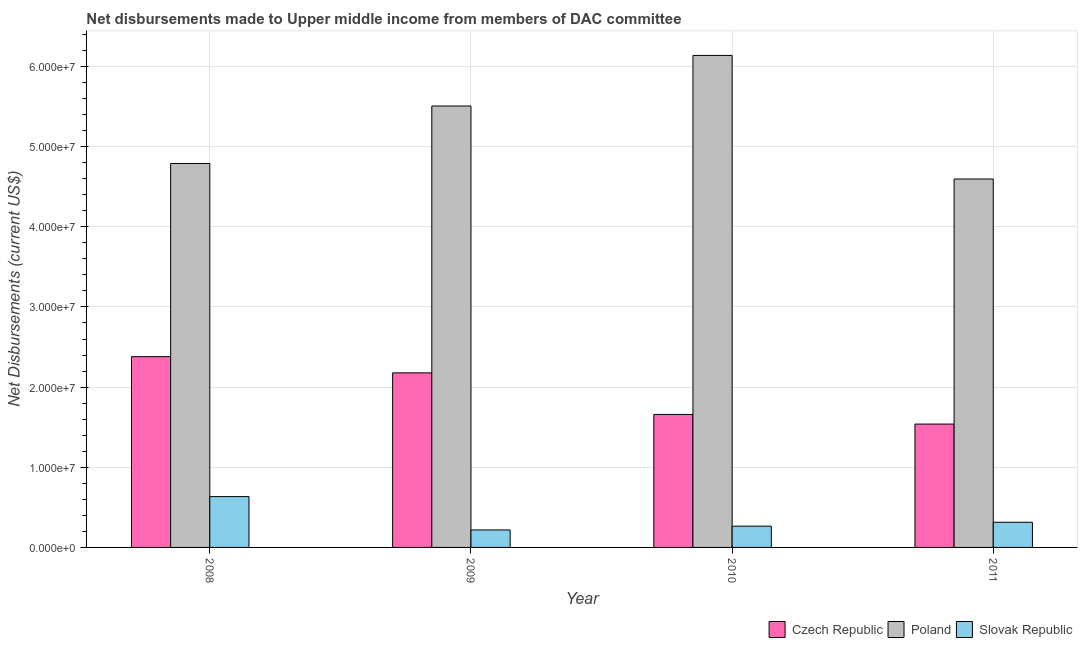How many groups of bars are there?
Keep it short and to the point. 4. Are the number of bars per tick equal to the number of legend labels?
Offer a very short reply. Yes. How many bars are there on the 1st tick from the left?
Offer a terse response. 3. How many bars are there on the 3rd tick from the right?
Your answer should be compact. 3. What is the label of the 1st group of bars from the left?
Provide a succinct answer. 2008. In how many cases, is the number of bars for a given year not equal to the number of legend labels?
Keep it short and to the point. 0. What is the net disbursements made by czech republic in 2008?
Provide a short and direct response. 2.38e+07. Across all years, what is the maximum net disbursements made by poland?
Provide a succinct answer. 6.14e+07. Across all years, what is the minimum net disbursements made by poland?
Your answer should be very brief. 4.60e+07. In which year was the net disbursements made by poland minimum?
Offer a very short reply. 2011. What is the total net disbursements made by czech republic in the graph?
Your response must be concise. 7.76e+07. What is the difference between the net disbursements made by poland in 2010 and that in 2011?
Ensure brevity in your answer.  1.54e+07. What is the difference between the net disbursements made by czech republic in 2011 and the net disbursements made by slovak republic in 2009?
Provide a short and direct response. -6.39e+06. What is the average net disbursements made by poland per year?
Offer a terse response. 5.26e+07. In the year 2010, what is the difference between the net disbursements made by poland and net disbursements made by czech republic?
Give a very brief answer. 0. In how many years, is the net disbursements made by czech republic greater than 24000000 US$?
Offer a terse response. 0. What is the ratio of the net disbursements made by slovak republic in 2008 to that in 2011?
Provide a succinct answer. 2.02. Is the difference between the net disbursements made by slovak republic in 2008 and 2009 greater than the difference between the net disbursements made by poland in 2008 and 2009?
Offer a terse response. No. What is the difference between the highest and the second highest net disbursements made by poland?
Your response must be concise. 6.31e+06. What is the difference between the highest and the lowest net disbursements made by poland?
Your response must be concise. 1.54e+07. What does the 3rd bar from the left in 2011 represents?
Ensure brevity in your answer.  Slovak Republic. What does the 1st bar from the right in 2008 represents?
Ensure brevity in your answer.  Slovak Republic. Is it the case that in every year, the sum of the net disbursements made by czech republic and net disbursements made by poland is greater than the net disbursements made by slovak republic?
Offer a very short reply. Yes. How many bars are there?
Offer a terse response. 12. How many years are there in the graph?
Ensure brevity in your answer.  4. What is the difference between two consecutive major ticks on the Y-axis?
Give a very brief answer. 1.00e+07. Does the graph contain grids?
Keep it short and to the point. Yes. How many legend labels are there?
Offer a terse response. 3. How are the legend labels stacked?
Offer a very short reply. Horizontal. What is the title of the graph?
Provide a short and direct response. Net disbursements made to Upper middle income from members of DAC committee. Does "Grants" appear as one of the legend labels in the graph?
Provide a succinct answer. No. What is the label or title of the Y-axis?
Offer a very short reply. Net Disbursements (current US$). What is the Net Disbursements (current US$) in Czech Republic in 2008?
Provide a succinct answer. 2.38e+07. What is the Net Disbursements (current US$) of Poland in 2008?
Your answer should be compact. 4.79e+07. What is the Net Disbursements (current US$) of Slovak Republic in 2008?
Your answer should be compact. 6.34e+06. What is the Net Disbursements (current US$) in Czech Republic in 2009?
Give a very brief answer. 2.18e+07. What is the Net Disbursements (current US$) of Poland in 2009?
Keep it short and to the point. 5.51e+07. What is the Net Disbursements (current US$) in Slovak Republic in 2009?
Give a very brief answer. 2.18e+06. What is the Net Disbursements (current US$) of Czech Republic in 2010?
Provide a succinct answer. 1.66e+07. What is the Net Disbursements (current US$) in Poland in 2010?
Give a very brief answer. 6.14e+07. What is the Net Disbursements (current US$) of Slovak Republic in 2010?
Your answer should be very brief. 2.65e+06. What is the Net Disbursements (current US$) in Czech Republic in 2011?
Provide a short and direct response. 1.54e+07. What is the Net Disbursements (current US$) in Poland in 2011?
Your answer should be very brief. 4.60e+07. What is the Net Disbursements (current US$) of Slovak Republic in 2011?
Offer a terse response. 3.14e+06. Across all years, what is the maximum Net Disbursements (current US$) in Czech Republic?
Offer a very short reply. 2.38e+07. Across all years, what is the maximum Net Disbursements (current US$) in Poland?
Offer a terse response. 6.14e+07. Across all years, what is the maximum Net Disbursements (current US$) of Slovak Republic?
Your response must be concise. 6.34e+06. Across all years, what is the minimum Net Disbursements (current US$) of Czech Republic?
Offer a terse response. 1.54e+07. Across all years, what is the minimum Net Disbursements (current US$) in Poland?
Your answer should be very brief. 4.60e+07. Across all years, what is the minimum Net Disbursements (current US$) of Slovak Republic?
Keep it short and to the point. 2.18e+06. What is the total Net Disbursements (current US$) of Czech Republic in the graph?
Your answer should be compact. 7.76e+07. What is the total Net Disbursements (current US$) of Poland in the graph?
Provide a short and direct response. 2.10e+08. What is the total Net Disbursements (current US$) in Slovak Republic in the graph?
Keep it short and to the point. 1.43e+07. What is the difference between the Net Disbursements (current US$) of Czech Republic in 2008 and that in 2009?
Offer a terse response. 2.02e+06. What is the difference between the Net Disbursements (current US$) in Poland in 2008 and that in 2009?
Keep it short and to the point. -7.17e+06. What is the difference between the Net Disbursements (current US$) in Slovak Republic in 2008 and that in 2009?
Your answer should be compact. 4.16e+06. What is the difference between the Net Disbursements (current US$) in Czech Republic in 2008 and that in 2010?
Your answer should be compact. 7.21e+06. What is the difference between the Net Disbursements (current US$) of Poland in 2008 and that in 2010?
Your response must be concise. -1.35e+07. What is the difference between the Net Disbursements (current US$) of Slovak Republic in 2008 and that in 2010?
Give a very brief answer. 3.69e+06. What is the difference between the Net Disbursements (current US$) of Czech Republic in 2008 and that in 2011?
Offer a terse response. 8.41e+06. What is the difference between the Net Disbursements (current US$) of Poland in 2008 and that in 2011?
Offer a terse response. 1.94e+06. What is the difference between the Net Disbursements (current US$) of Slovak Republic in 2008 and that in 2011?
Your answer should be compact. 3.20e+06. What is the difference between the Net Disbursements (current US$) in Czech Republic in 2009 and that in 2010?
Make the answer very short. 5.19e+06. What is the difference between the Net Disbursements (current US$) of Poland in 2009 and that in 2010?
Your answer should be compact. -6.31e+06. What is the difference between the Net Disbursements (current US$) of Slovak Republic in 2009 and that in 2010?
Your response must be concise. -4.70e+05. What is the difference between the Net Disbursements (current US$) of Czech Republic in 2009 and that in 2011?
Provide a short and direct response. 6.39e+06. What is the difference between the Net Disbursements (current US$) in Poland in 2009 and that in 2011?
Your answer should be compact. 9.11e+06. What is the difference between the Net Disbursements (current US$) of Slovak Republic in 2009 and that in 2011?
Offer a very short reply. -9.60e+05. What is the difference between the Net Disbursements (current US$) in Czech Republic in 2010 and that in 2011?
Your answer should be compact. 1.20e+06. What is the difference between the Net Disbursements (current US$) in Poland in 2010 and that in 2011?
Ensure brevity in your answer.  1.54e+07. What is the difference between the Net Disbursements (current US$) of Slovak Republic in 2010 and that in 2011?
Keep it short and to the point. -4.90e+05. What is the difference between the Net Disbursements (current US$) in Czech Republic in 2008 and the Net Disbursements (current US$) in Poland in 2009?
Keep it short and to the point. -3.13e+07. What is the difference between the Net Disbursements (current US$) in Czech Republic in 2008 and the Net Disbursements (current US$) in Slovak Republic in 2009?
Keep it short and to the point. 2.16e+07. What is the difference between the Net Disbursements (current US$) of Poland in 2008 and the Net Disbursements (current US$) of Slovak Republic in 2009?
Provide a short and direct response. 4.57e+07. What is the difference between the Net Disbursements (current US$) in Czech Republic in 2008 and the Net Disbursements (current US$) in Poland in 2010?
Keep it short and to the point. -3.76e+07. What is the difference between the Net Disbursements (current US$) of Czech Republic in 2008 and the Net Disbursements (current US$) of Slovak Republic in 2010?
Offer a very short reply. 2.12e+07. What is the difference between the Net Disbursements (current US$) of Poland in 2008 and the Net Disbursements (current US$) of Slovak Republic in 2010?
Provide a short and direct response. 4.52e+07. What is the difference between the Net Disbursements (current US$) of Czech Republic in 2008 and the Net Disbursements (current US$) of Poland in 2011?
Your answer should be compact. -2.22e+07. What is the difference between the Net Disbursements (current US$) of Czech Republic in 2008 and the Net Disbursements (current US$) of Slovak Republic in 2011?
Keep it short and to the point. 2.07e+07. What is the difference between the Net Disbursements (current US$) of Poland in 2008 and the Net Disbursements (current US$) of Slovak Republic in 2011?
Offer a very short reply. 4.48e+07. What is the difference between the Net Disbursements (current US$) of Czech Republic in 2009 and the Net Disbursements (current US$) of Poland in 2010?
Provide a short and direct response. -3.96e+07. What is the difference between the Net Disbursements (current US$) in Czech Republic in 2009 and the Net Disbursements (current US$) in Slovak Republic in 2010?
Offer a very short reply. 1.91e+07. What is the difference between the Net Disbursements (current US$) of Poland in 2009 and the Net Disbursements (current US$) of Slovak Republic in 2010?
Ensure brevity in your answer.  5.24e+07. What is the difference between the Net Disbursements (current US$) of Czech Republic in 2009 and the Net Disbursements (current US$) of Poland in 2011?
Provide a succinct answer. -2.42e+07. What is the difference between the Net Disbursements (current US$) of Czech Republic in 2009 and the Net Disbursements (current US$) of Slovak Republic in 2011?
Provide a succinct answer. 1.86e+07. What is the difference between the Net Disbursements (current US$) in Poland in 2009 and the Net Disbursements (current US$) in Slovak Republic in 2011?
Your answer should be compact. 5.19e+07. What is the difference between the Net Disbursements (current US$) in Czech Republic in 2010 and the Net Disbursements (current US$) in Poland in 2011?
Provide a short and direct response. -2.94e+07. What is the difference between the Net Disbursements (current US$) in Czech Republic in 2010 and the Net Disbursements (current US$) in Slovak Republic in 2011?
Offer a terse response. 1.34e+07. What is the difference between the Net Disbursements (current US$) of Poland in 2010 and the Net Disbursements (current US$) of Slovak Republic in 2011?
Your answer should be compact. 5.82e+07. What is the average Net Disbursements (current US$) in Czech Republic per year?
Keep it short and to the point. 1.94e+07. What is the average Net Disbursements (current US$) of Poland per year?
Your answer should be compact. 5.26e+07. What is the average Net Disbursements (current US$) of Slovak Republic per year?
Ensure brevity in your answer.  3.58e+06. In the year 2008, what is the difference between the Net Disbursements (current US$) of Czech Republic and Net Disbursements (current US$) of Poland?
Provide a succinct answer. -2.41e+07. In the year 2008, what is the difference between the Net Disbursements (current US$) in Czech Republic and Net Disbursements (current US$) in Slovak Republic?
Keep it short and to the point. 1.75e+07. In the year 2008, what is the difference between the Net Disbursements (current US$) of Poland and Net Disbursements (current US$) of Slovak Republic?
Make the answer very short. 4.16e+07. In the year 2009, what is the difference between the Net Disbursements (current US$) of Czech Republic and Net Disbursements (current US$) of Poland?
Offer a very short reply. -3.33e+07. In the year 2009, what is the difference between the Net Disbursements (current US$) in Czech Republic and Net Disbursements (current US$) in Slovak Republic?
Offer a very short reply. 1.96e+07. In the year 2009, what is the difference between the Net Disbursements (current US$) of Poland and Net Disbursements (current US$) of Slovak Republic?
Give a very brief answer. 5.29e+07. In the year 2010, what is the difference between the Net Disbursements (current US$) in Czech Republic and Net Disbursements (current US$) in Poland?
Your response must be concise. -4.48e+07. In the year 2010, what is the difference between the Net Disbursements (current US$) in Czech Republic and Net Disbursements (current US$) in Slovak Republic?
Make the answer very short. 1.39e+07. In the year 2010, what is the difference between the Net Disbursements (current US$) of Poland and Net Disbursements (current US$) of Slovak Republic?
Ensure brevity in your answer.  5.87e+07. In the year 2011, what is the difference between the Net Disbursements (current US$) in Czech Republic and Net Disbursements (current US$) in Poland?
Offer a terse response. -3.06e+07. In the year 2011, what is the difference between the Net Disbursements (current US$) in Czech Republic and Net Disbursements (current US$) in Slovak Republic?
Keep it short and to the point. 1.22e+07. In the year 2011, what is the difference between the Net Disbursements (current US$) in Poland and Net Disbursements (current US$) in Slovak Republic?
Provide a succinct answer. 4.28e+07. What is the ratio of the Net Disbursements (current US$) in Czech Republic in 2008 to that in 2009?
Your answer should be very brief. 1.09. What is the ratio of the Net Disbursements (current US$) of Poland in 2008 to that in 2009?
Your response must be concise. 0.87. What is the ratio of the Net Disbursements (current US$) in Slovak Republic in 2008 to that in 2009?
Ensure brevity in your answer.  2.91. What is the ratio of the Net Disbursements (current US$) in Czech Republic in 2008 to that in 2010?
Give a very brief answer. 1.43. What is the ratio of the Net Disbursements (current US$) of Poland in 2008 to that in 2010?
Keep it short and to the point. 0.78. What is the ratio of the Net Disbursements (current US$) of Slovak Republic in 2008 to that in 2010?
Keep it short and to the point. 2.39. What is the ratio of the Net Disbursements (current US$) in Czech Republic in 2008 to that in 2011?
Your answer should be compact. 1.55. What is the ratio of the Net Disbursements (current US$) in Poland in 2008 to that in 2011?
Ensure brevity in your answer.  1.04. What is the ratio of the Net Disbursements (current US$) of Slovak Republic in 2008 to that in 2011?
Provide a short and direct response. 2.02. What is the ratio of the Net Disbursements (current US$) in Czech Republic in 2009 to that in 2010?
Keep it short and to the point. 1.31. What is the ratio of the Net Disbursements (current US$) of Poland in 2009 to that in 2010?
Offer a very short reply. 0.9. What is the ratio of the Net Disbursements (current US$) in Slovak Republic in 2009 to that in 2010?
Keep it short and to the point. 0.82. What is the ratio of the Net Disbursements (current US$) of Czech Republic in 2009 to that in 2011?
Keep it short and to the point. 1.42. What is the ratio of the Net Disbursements (current US$) of Poland in 2009 to that in 2011?
Make the answer very short. 1.2. What is the ratio of the Net Disbursements (current US$) in Slovak Republic in 2009 to that in 2011?
Give a very brief answer. 0.69. What is the ratio of the Net Disbursements (current US$) in Czech Republic in 2010 to that in 2011?
Your answer should be compact. 1.08. What is the ratio of the Net Disbursements (current US$) in Poland in 2010 to that in 2011?
Your response must be concise. 1.34. What is the ratio of the Net Disbursements (current US$) of Slovak Republic in 2010 to that in 2011?
Your answer should be very brief. 0.84. What is the difference between the highest and the second highest Net Disbursements (current US$) in Czech Republic?
Your response must be concise. 2.02e+06. What is the difference between the highest and the second highest Net Disbursements (current US$) of Poland?
Keep it short and to the point. 6.31e+06. What is the difference between the highest and the second highest Net Disbursements (current US$) of Slovak Republic?
Your response must be concise. 3.20e+06. What is the difference between the highest and the lowest Net Disbursements (current US$) in Czech Republic?
Provide a short and direct response. 8.41e+06. What is the difference between the highest and the lowest Net Disbursements (current US$) in Poland?
Provide a short and direct response. 1.54e+07. What is the difference between the highest and the lowest Net Disbursements (current US$) in Slovak Republic?
Your response must be concise. 4.16e+06. 